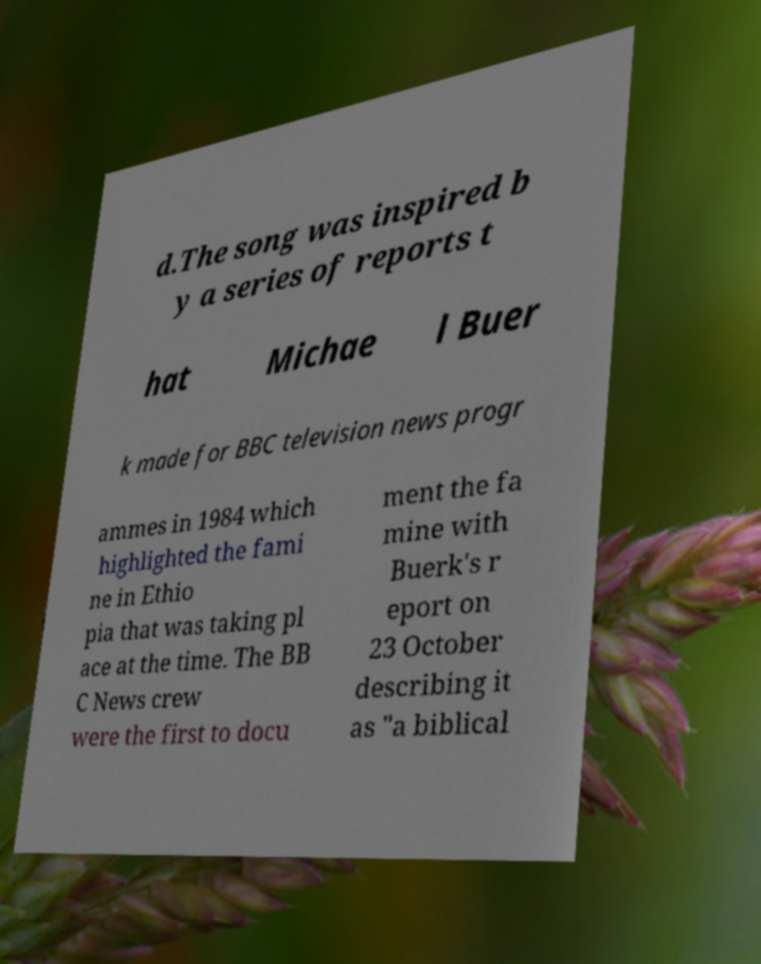Can you accurately transcribe the text from the provided image for me? d.The song was inspired b y a series of reports t hat Michae l Buer k made for BBC television news progr ammes in 1984 which highlighted the fami ne in Ethio pia that was taking pl ace at the time. The BB C News crew were the first to docu ment the fa mine with Buerk's r eport on 23 October describing it as "a biblical 